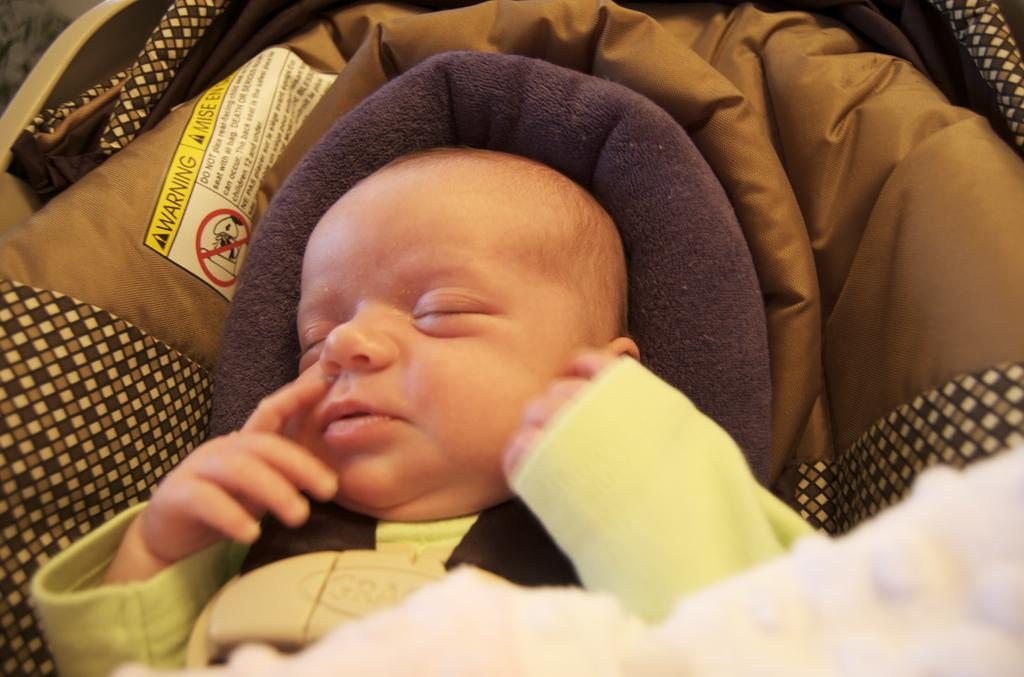What is the main subject of the image? There is a baby in the image. What is the baby doing in the image? The baby is sleeping. Where is the baby located in the image? The baby is on a bed. What is the color of the bed? The bed is brown in color. What is at the bottom of the bed? There is a blanket at the bottom of the bed. What new discovery has the baby made in the image? There is no indication in the image that the baby has made any new discovery. 